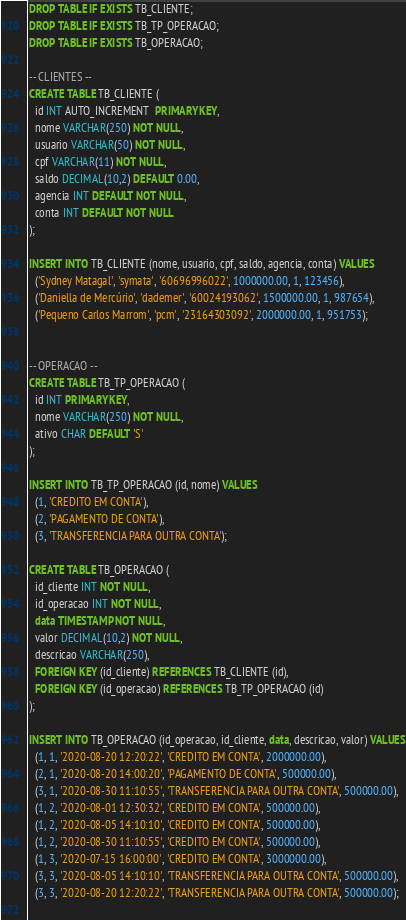<code> <loc_0><loc_0><loc_500><loc_500><_SQL_>DROP TABLE IF EXISTS TB_CLIENTE;
DROP TABLE IF EXISTS TB_TP_OPERACAO;
DROP TABLE IF EXISTS TB_OPERACAO;

-- CLIENTES --
CREATE TABLE TB_CLIENTE (
  id INT AUTO_INCREMENT  PRIMARY KEY,
  nome VARCHAR(250) NOT NULL,
  usuario VARCHAR(50) NOT NULL,
  cpf VARCHAR(11) NOT NULL,
  saldo DECIMAL(10,2) DEFAULT 0.00,
  agencia INT DEFAULT NOT NULL,
  conta INT DEFAULT NOT NULL
);

INSERT INTO TB_CLIENTE (nome, usuario, cpf, saldo, agencia, conta) VALUES
  ('Sydney Matagal', 'symata', '60696996022', 1000000.00, 1, 123456),
  ('Daniella de Mercúrio', 'dademer', '60024193062', 1500000.00, 1, 987654),
  ('Pequeno Carlos Marrom', 'pcm', '23164303092', 2000000.00, 1, 951753);
  
  
-- OPERACAO --
CREATE TABLE TB_TP_OPERACAO (
  id INT PRIMARY KEY,
  nome VARCHAR(250) NOT NULL,
  ativo CHAR DEFAULT 'S'
);

INSERT INTO TB_TP_OPERACAO (id, nome) VALUES
  (1, 'CREDITO EM CONTA'),
  (2, 'PAGAMENTO DE CONTA'),
  (3, 'TRANSFERENCIA PARA OUTRA CONTA');
 
CREATE TABLE TB_OPERACAO (
  id_cliente INT NOT NULL,
  id_operacao INT NOT NULL,
  data TIMESTAMP NOT NULL,
  valor DECIMAL(10,2) NOT NULL,
  descricao VARCHAR(250),
  FOREIGN KEY (id_cliente) REFERENCES TB_CLIENTE (id),
  FOREIGN KEY (id_operacao) REFERENCES TB_TP_OPERACAO (id)
);

INSERT INTO TB_OPERACAO (id_operacao, id_cliente, data, descricao, valor) VALUES
  (1, 1, '2020-08-20 12:20:22', 'CREDITO EM CONTA', 2000000.00),
  (2, 1, '2020-08-20 14:00:20', 'PAGAMENTO DE CONTA', 500000.00),
  (3, 1, '2020-08-30 11:10:55', 'TRANSFERENCIA PARA OUTRA CONTA', 500000.00),
  (1, 2, '2020-08-01 12:30:32', 'CREDITO EM CONTA', 500000.00),
  (1, 2, '2020-08-05 14:10:10', 'CREDITO EM CONTA', 500000.00),
  (1, 2, '2020-08-30 11:10:55', 'CREDITO EM CONTA', 500000.00),
  (1, 3, '2020-07-15 16:00:00', 'CREDITO EM CONTA', 3000000.00),
  (3, 3, '2020-08-05 14:10:10', 'TRANSFERENCIA PARA OUTRA CONTA', 500000.00),
  (3, 3, '2020-08-20 12:20:22', 'TRANSFERENCIA PARA OUTRA CONTA', 500000.00);
 </code> 